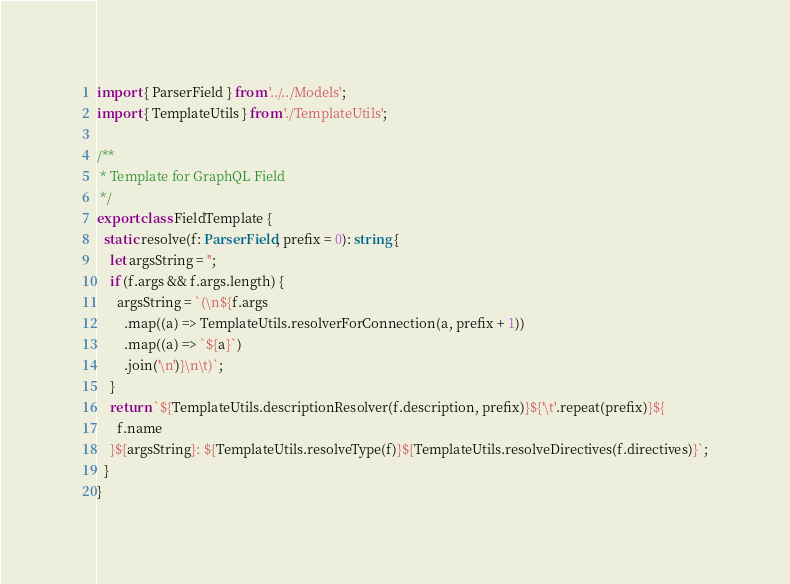<code> <loc_0><loc_0><loc_500><loc_500><_TypeScript_>import { ParserField } from '../../Models';
import { TemplateUtils } from './TemplateUtils';

/**
 * Template for GraphQL Field
 */
export class FieldTemplate {
  static resolve(f: ParserField, prefix = 0): string {
    let argsString = '';
    if (f.args && f.args.length) {
      argsString = `(\n${f.args
        .map((a) => TemplateUtils.resolverForConnection(a, prefix + 1))
        .map((a) => `${a}`)
        .join('\n')}\n\t)`;
    }
    return `${TemplateUtils.descriptionResolver(f.description, prefix)}${'\t'.repeat(prefix)}${
      f.name
    }${argsString}: ${TemplateUtils.resolveType(f)}${TemplateUtils.resolveDirectives(f.directives)}`;
  }
}
</code> 